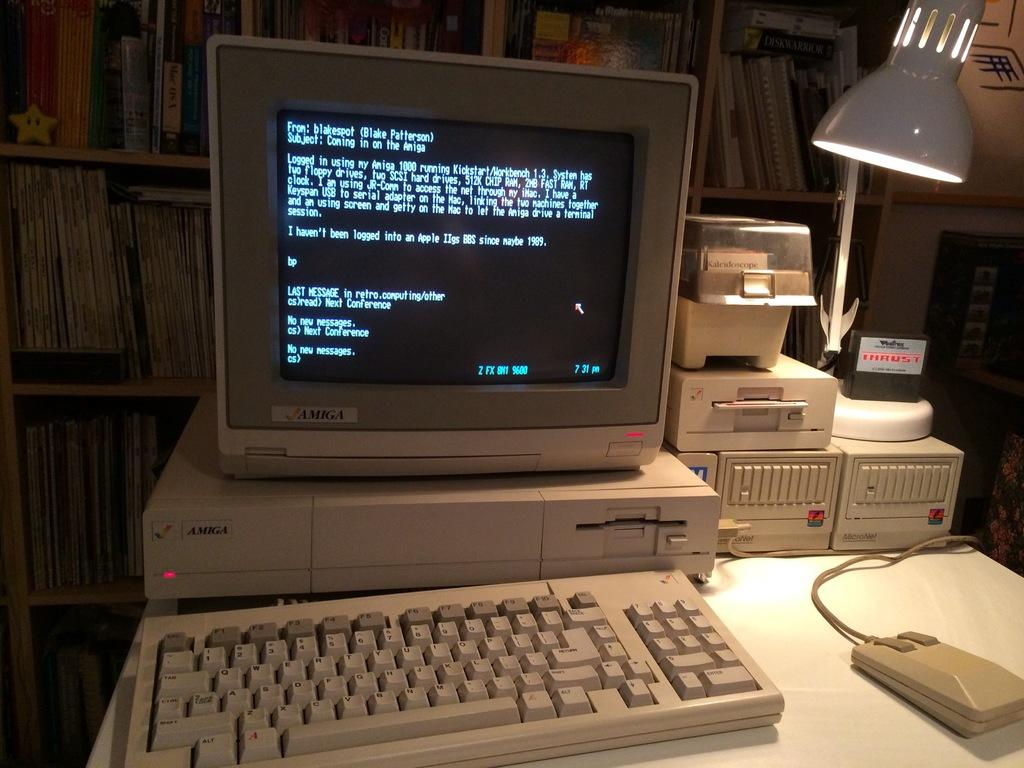What electronic device is visible in the image? There is a monitor in the image. What is used for input with the monitor? There is a keyboard and a mouse in the image, which are used for input. What is the source of light in the image? There is a lamp in the image, which provides light. Where are the monitor, keyboard, mouse, and lamp located? They are placed on a table in the image. What can be seen in the background of the image? There is a group of books placed in a rack in the background of the image. How many needles are used to create the nest in the image? There is no nest or needles present in the image. How does the quiet environment in the image affect the user's productivity? The image does not provide information about the environment's quietness or how it might affect productivity. 